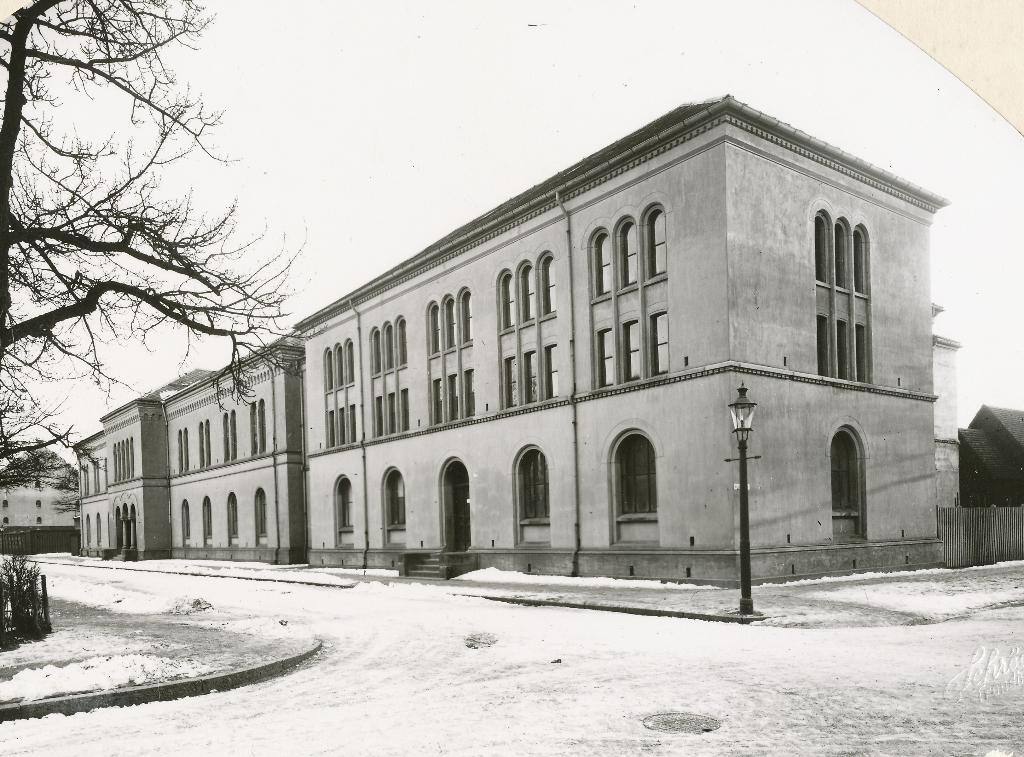What is the color scheme of the image? The image is black and white. What is the condition of the land in the image? The land is covered with snow. What structure can be seen in the image? There is a light pole in the image. What can be seen in the background of the image? There is a building in the background of the image. What type of vegetation is on the left side of the image? There is a tree on the left side of the image. What type of guitar can be seen hanging from the tree in the image? There is no guitar present in the image; it features a tree in a snowy landscape. 